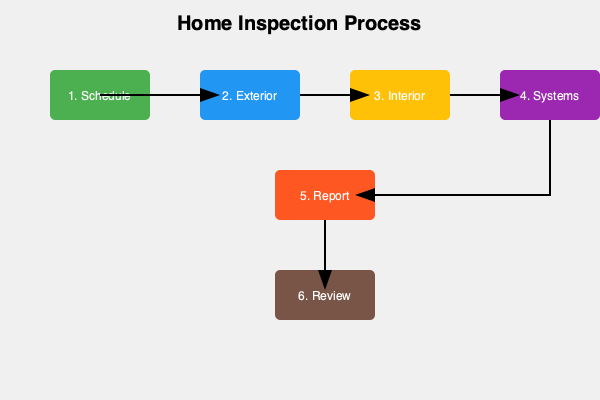According to the infographic, which step in the home inspection process immediately precedes the generation of the inspection report? To answer this question, we need to analyze the flow of the home inspection process as depicted in the infographic:

1. The process starts with "Schedule" (green box).
2. It then moves to "Exterior" inspection (blue box).
3. Next is the "Interior" inspection (yellow box).
4. Following that is the "Systems" inspection (purple box).
5. After the systems inspection, we see an arrow pointing to "Report" (orange box).
6. Finally, the process ends with "Review" (brown box).

The question asks about the step that comes immediately before the report generation. By following the arrows in the infographic, we can see that the "Systems" inspection (step 4) directly leads to the "Report" generation (step 5).

Therefore, the step that immediately precedes the generation of the inspection report is the inspection of the home's systems.
Answer: Systems inspection 